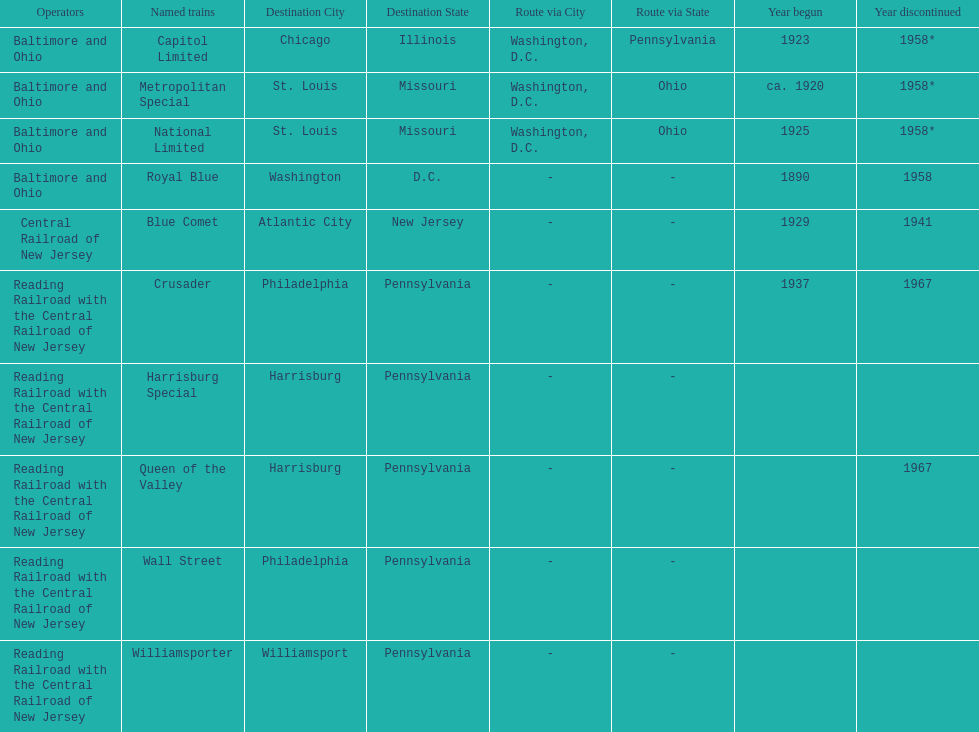Which operators are the reading railroad with the central railroad of new jersey? Reading Railroad with the Central Railroad of New Jersey, Reading Railroad with the Central Railroad of New Jersey, Reading Railroad with the Central Railroad of New Jersey, Reading Railroad with the Central Railroad of New Jersey, Reading Railroad with the Central Railroad of New Jersey. Which destinations are philadelphia, pennsylvania? Philadelphia, Pennsylvania, Philadelphia, Pennsylvania. What on began in 1937? 1937. What is the named train? Crusader. 